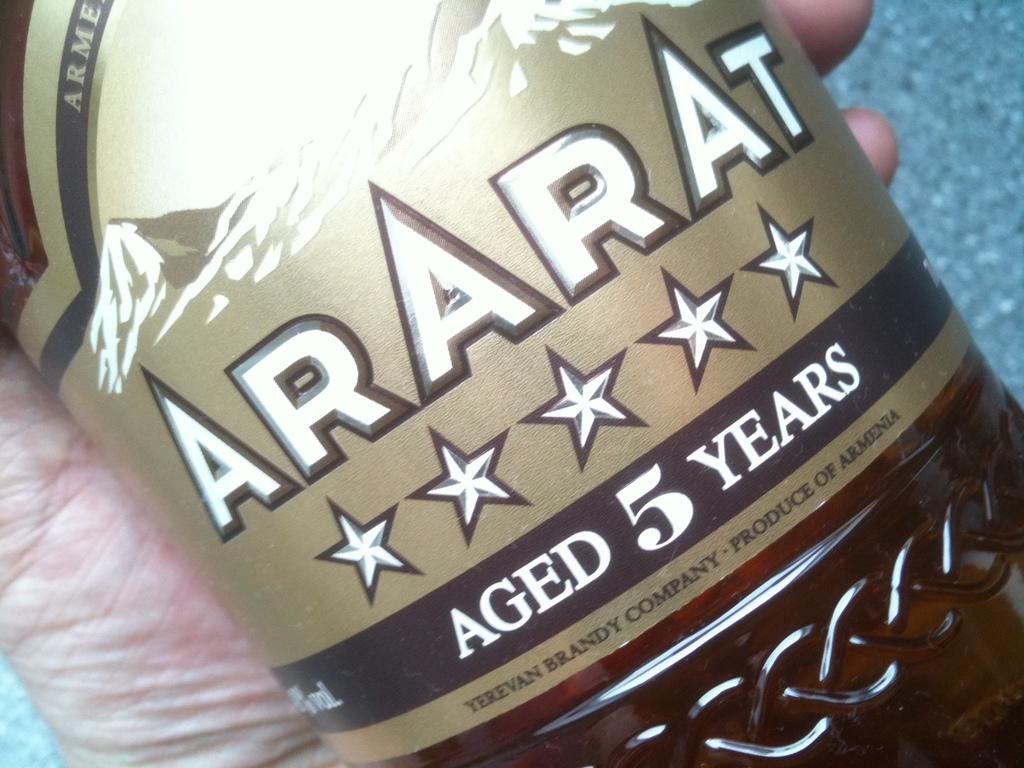What is being held by the hand in the image? The hand is holding a bottle. What can be seen on the bottle? The bottle has a label on it. What is the cause of the space anomaly in the image? There is no space anomaly present in the image; it features a human hand holding a bottle with a label on it. 